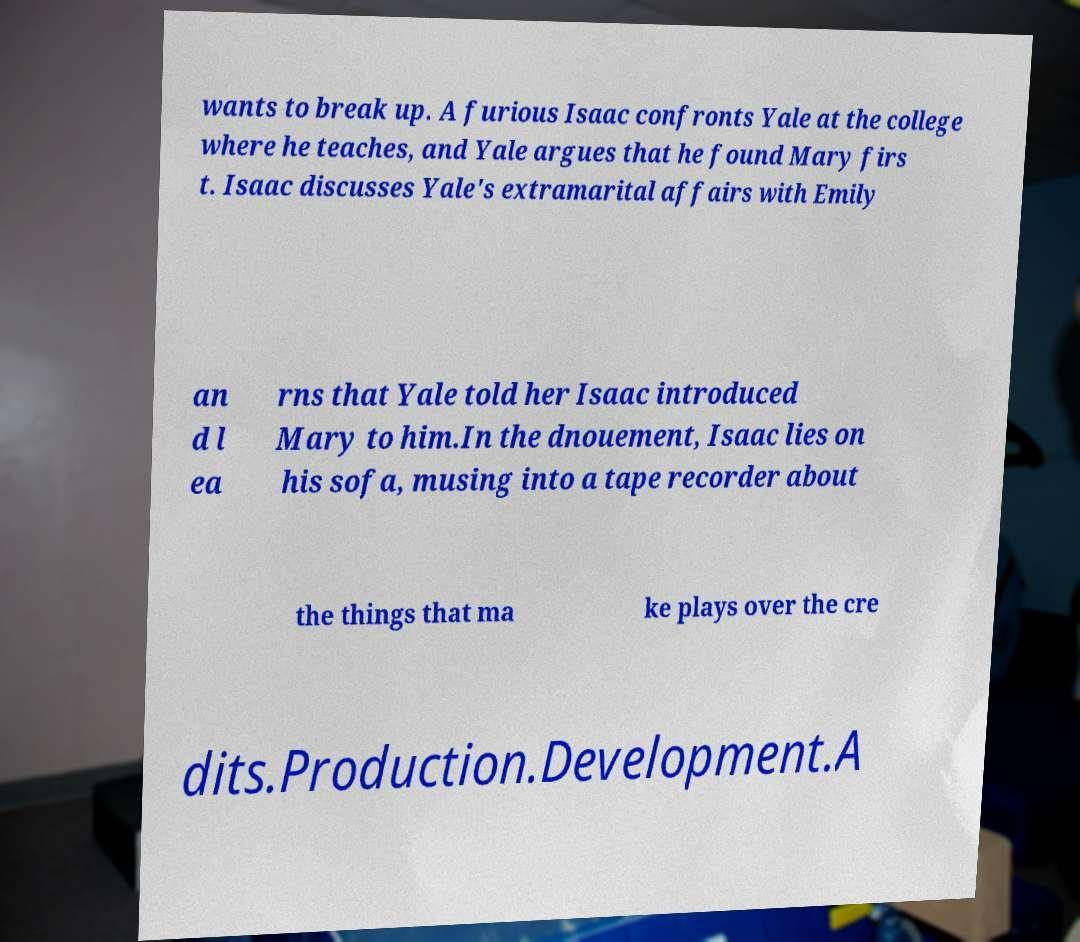There's text embedded in this image that I need extracted. Can you transcribe it verbatim? wants to break up. A furious Isaac confronts Yale at the college where he teaches, and Yale argues that he found Mary firs t. Isaac discusses Yale's extramarital affairs with Emily an d l ea rns that Yale told her Isaac introduced Mary to him.In the dnouement, Isaac lies on his sofa, musing into a tape recorder about the things that ma ke plays over the cre dits.Production.Development.A 